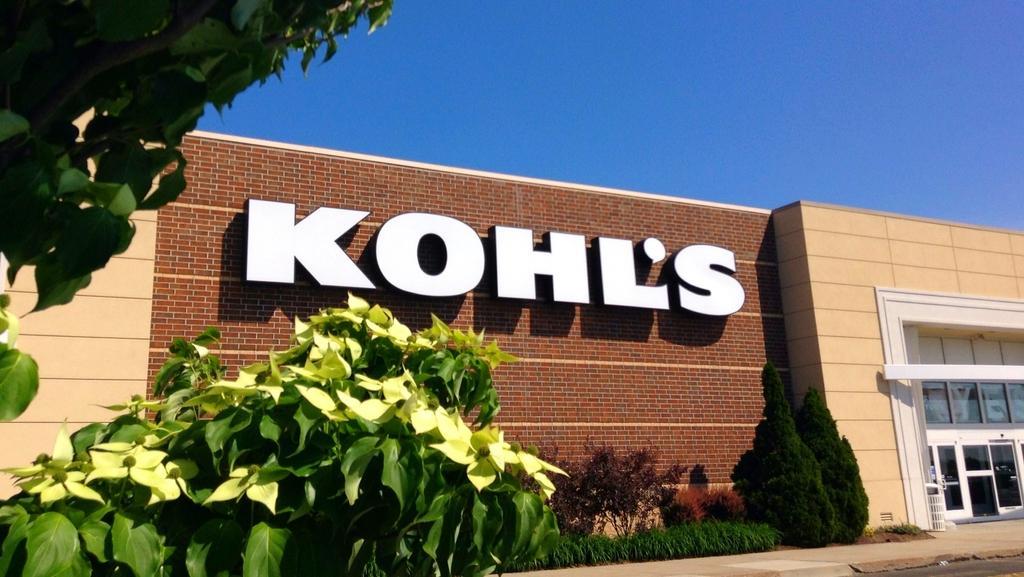Describe this image in one or two sentences. In this image, we can see a brick, house, glass doors, dustbin, few plants, trees. At the bottom, there is a road and footpath. Top of the image, we can see the sky. 